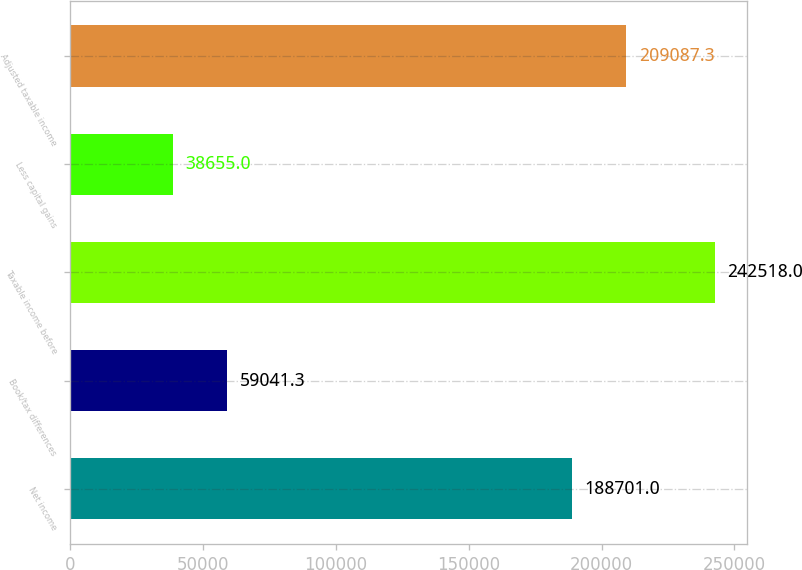<chart> <loc_0><loc_0><loc_500><loc_500><bar_chart><fcel>Net income<fcel>Book/tax differences<fcel>Taxable income before<fcel>Less capital gains<fcel>Adjusted taxable income<nl><fcel>188701<fcel>59041.3<fcel>242518<fcel>38655<fcel>209087<nl></chart> 